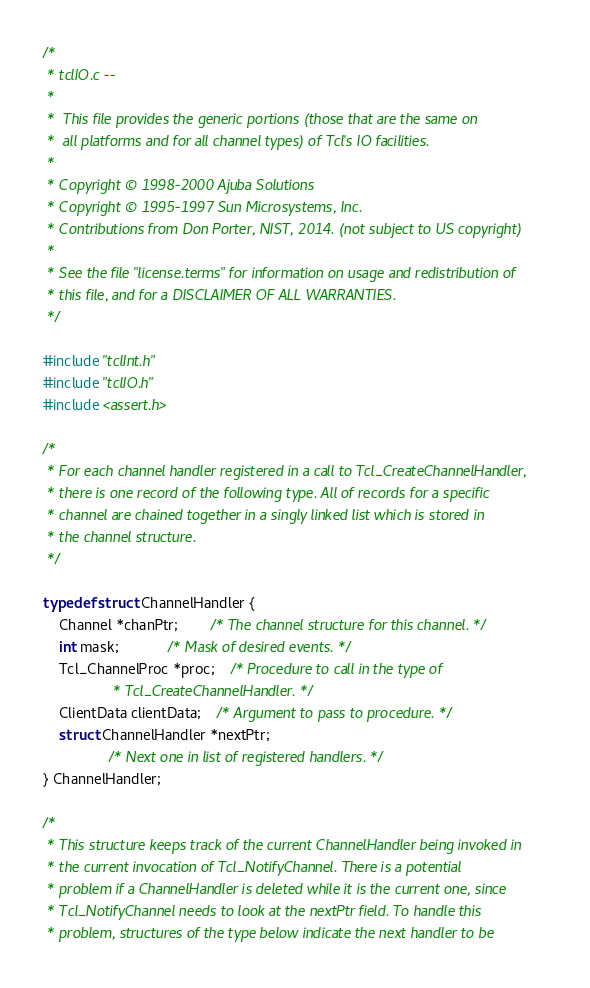<code> <loc_0><loc_0><loc_500><loc_500><_C_>/*
 * tclIO.c --
 *
 *	This file provides the generic portions (those that are the same on
 *	all platforms and for all channel types) of Tcl's IO facilities.
 *
 * Copyright © 1998-2000 Ajuba Solutions
 * Copyright © 1995-1997 Sun Microsystems, Inc.
 * Contributions from Don Porter, NIST, 2014. (not subject to US copyright)
 *
 * See the file "license.terms" for information on usage and redistribution of
 * this file, and for a DISCLAIMER OF ALL WARRANTIES.
 */

#include "tclInt.h"
#include "tclIO.h"
#include <assert.h>

/*
 * For each channel handler registered in a call to Tcl_CreateChannelHandler,
 * there is one record of the following type. All of records for a specific
 * channel are chained together in a singly linked list which is stored in
 * the channel structure.
 */

typedef struct ChannelHandler {
    Channel *chanPtr;		/* The channel structure for this channel. */
    int mask;			/* Mask of desired events. */
    Tcl_ChannelProc *proc;	/* Procedure to call in the type of
				 * Tcl_CreateChannelHandler. */
    ClientData clientData;	/* Argument to pass to procedure. */
    struct ChannelHandler *nextPtr;
				/* Next one in list of registered handlers. */
} ChannelHandler;

/*
 * This structure keeps track of the current ChannelHandler being invoked in
 * the current invocation of Tcl_NotifyChannel. There is a potential
 * problem if a ChannelHandler is deleted while it is the current one, since
 * Tcl_NotifyChannel needs to look at the nextPtr field. To handle this
 * problem, structures of the type below indicate the next handler to be</code> 